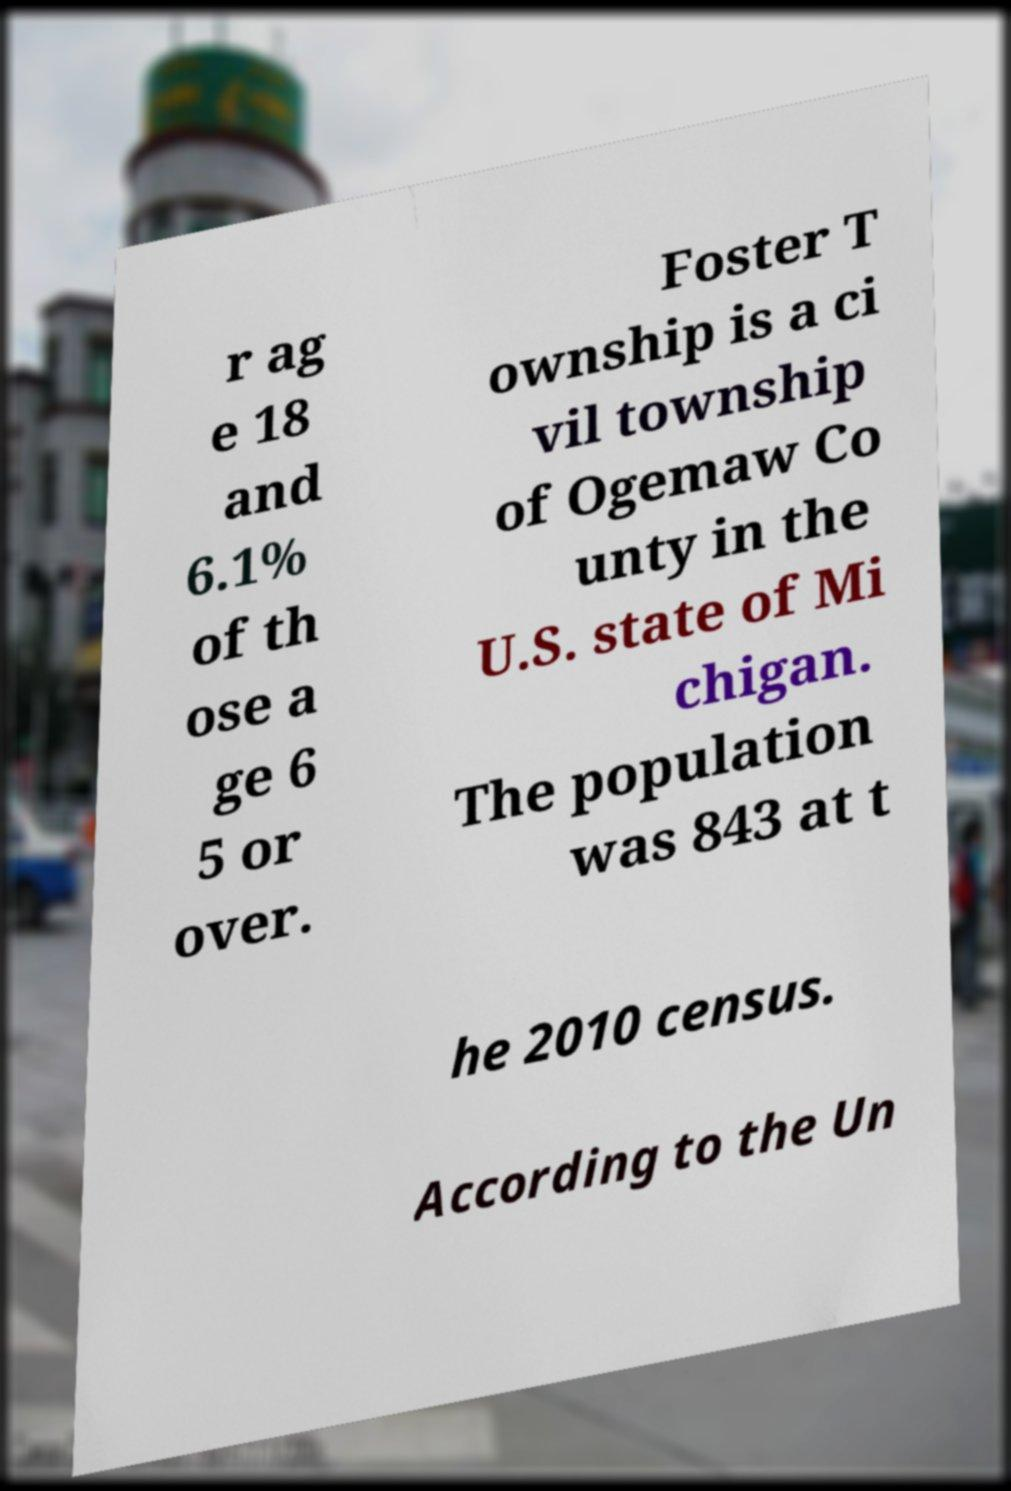For documentation purposes, I need the text within this image transcribed. Could you provide that? r ag e 18 and 6.1% of th ose a ge 6 5 or over. Foster T ownship is a ci vil township of Ogemaw Co unty in the U.S. state of Mi chigan. The population was 843 at t he 2010 census. According to the Un 